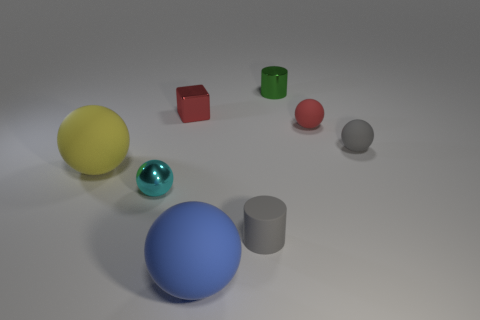Subtract 2 balls. How many balls are left? 3 Subtract all green spheres. Subtract all cyan cubes. How many spheres are left? 5 Add 1 large purple spheres. How many objects exist? 9 Subtract all spheres. How many objects are left? 3 Subtract 0 cyan cubes. How many objects are left? 8 Subtract all green rubber cylinders. Subtract all blue spheres. How many objects are left? 7 Add 7 small gray matte cylinders. How many small gray matte cylinders are left? 8 Add 4 balls. How many balls exist? 9 